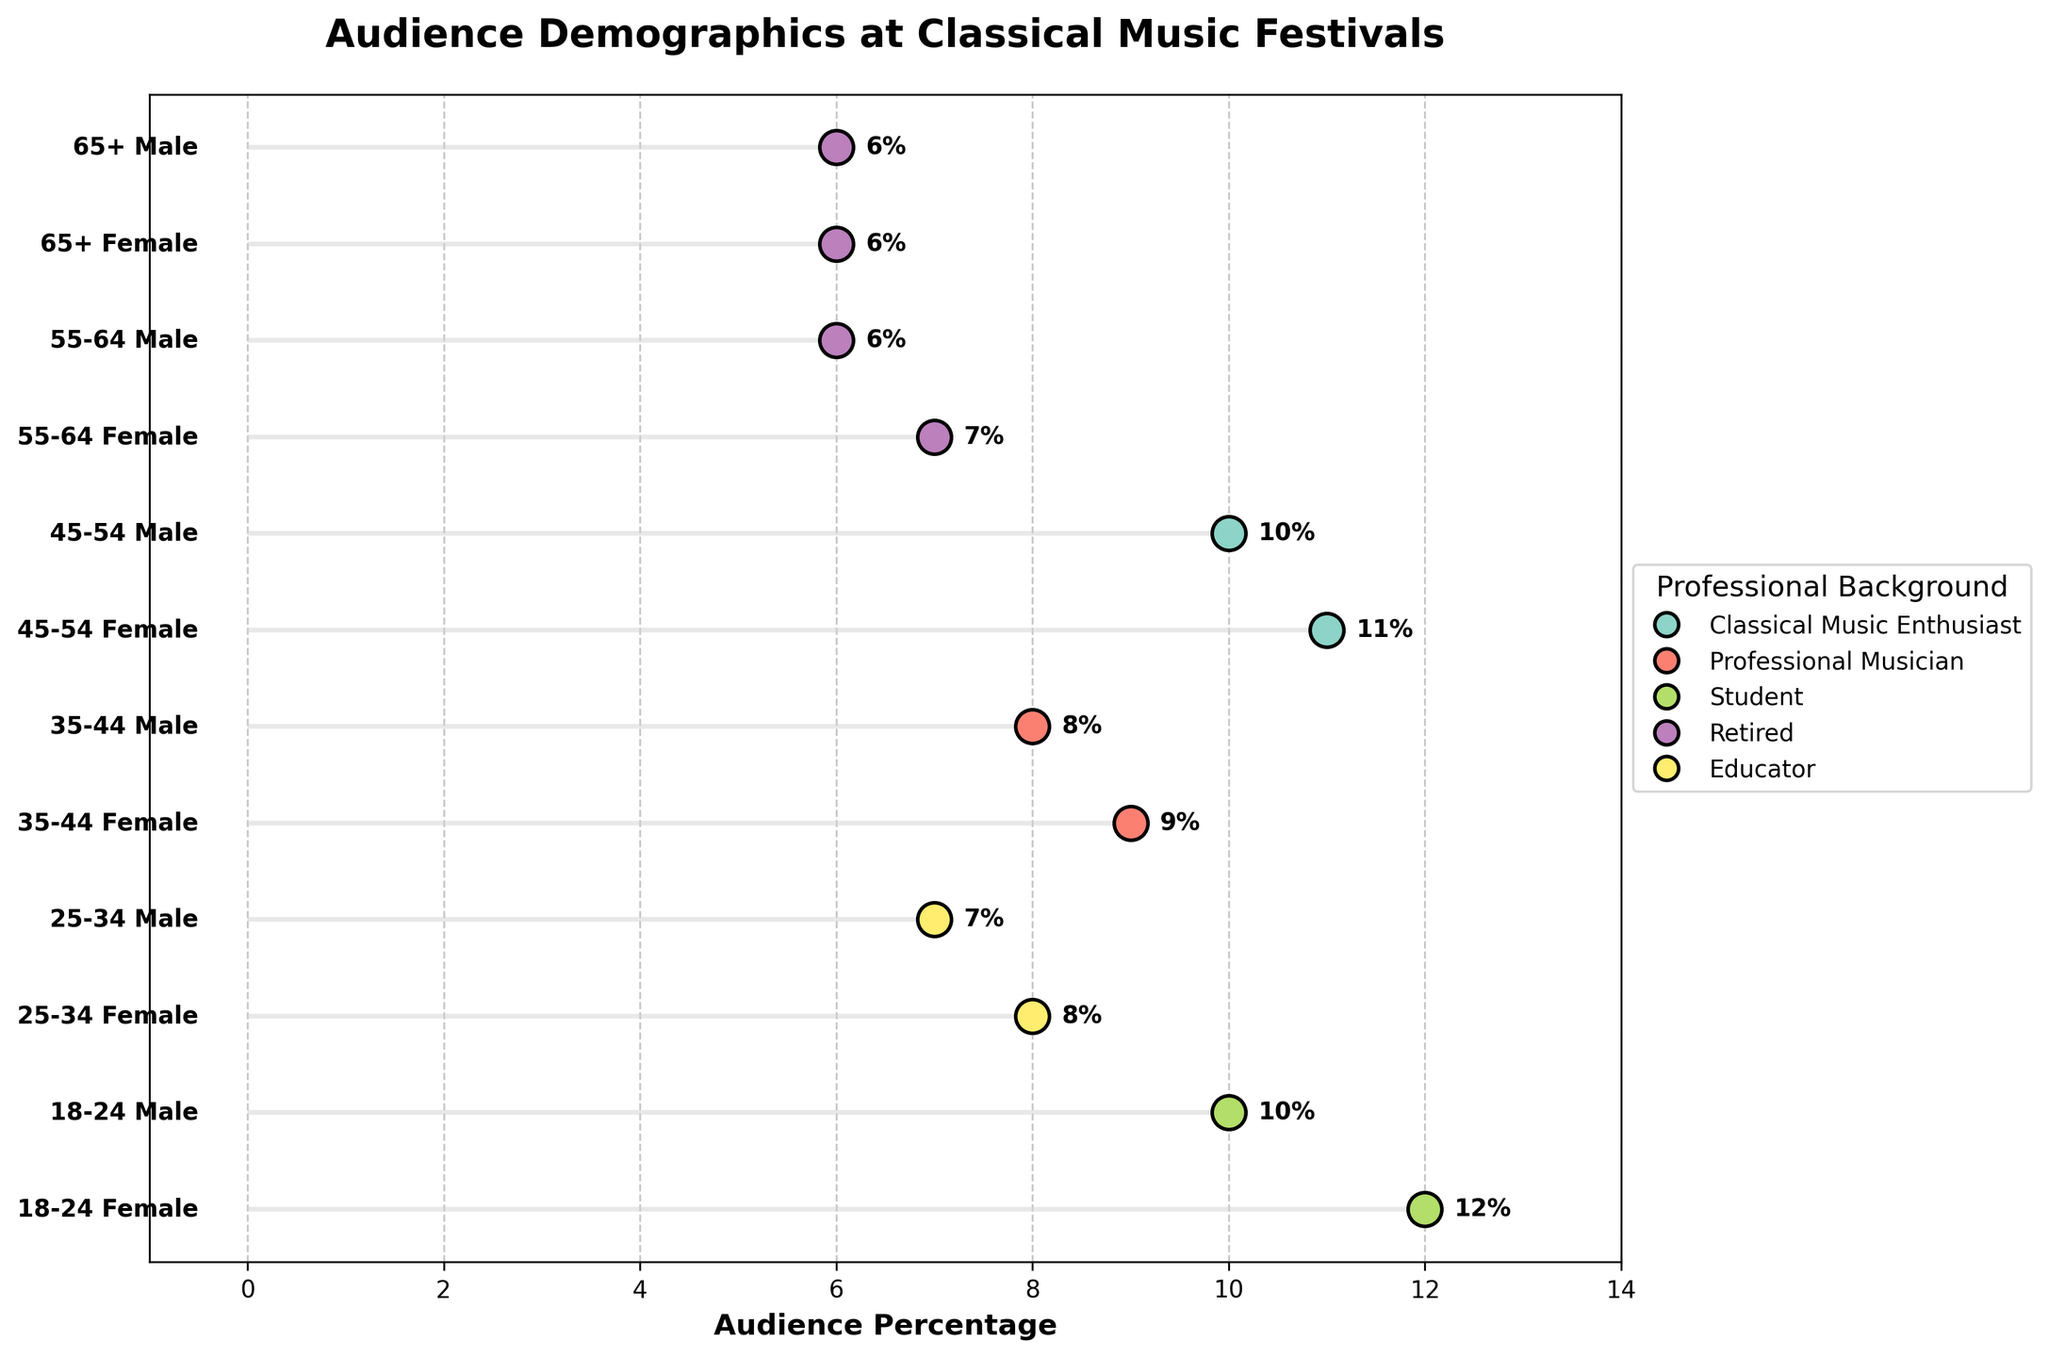What is the title of the plot? The title is prominently displayed at the top of the plot.
Answer: Audience Demographics at Classical Music Festivals Which professional background has the highest representation among females aged 45-54? Look for the dot representing female classical music enthusiasts aged 45-54 and check the corresponding professional background.
Answer: Classical Music Enthusiast How many professional backgrounds are represented in the plot? Identify the unique professional backgrounds in the legend section of the plot.
Answer: 5 Which age group and gender have the highest audience percentage? Find the longest horizontal line and check the associated age group and gender.
Answer: Female, 18-24 Compare the audience percentages of Male and Female retired individuals aged 55-64. Identify the dots that correspond to these groups and read their percentages.
Answer: 7% for Female, 6% for Male What is the total audience percentage for individuals aged 45-54? Add the percentages for male and female individuals aged 45-54.
Answer: 21% Which age group has the lowest representation among male audiences? Find the age group with the smallest percentage among male audiences.
Answer: 65+ Among students, which gender has a higher audience percentage in the 18-24 age group? Compare the audience percentages for male and female students aged 18-24.
Answer: Female What is the difference in audience percentage between female and male professional musicians aged 35-44? Subtract the percentage of male professional musicians from that of female professional musicians in the 35-44 age group.
Answer: 1% Which two professional backgrounds share the same audience percentage among males aged 65+? Find the dots for male retired individuals aged 65+ and check their professional backgrounds.
Answer: Both are Retired 